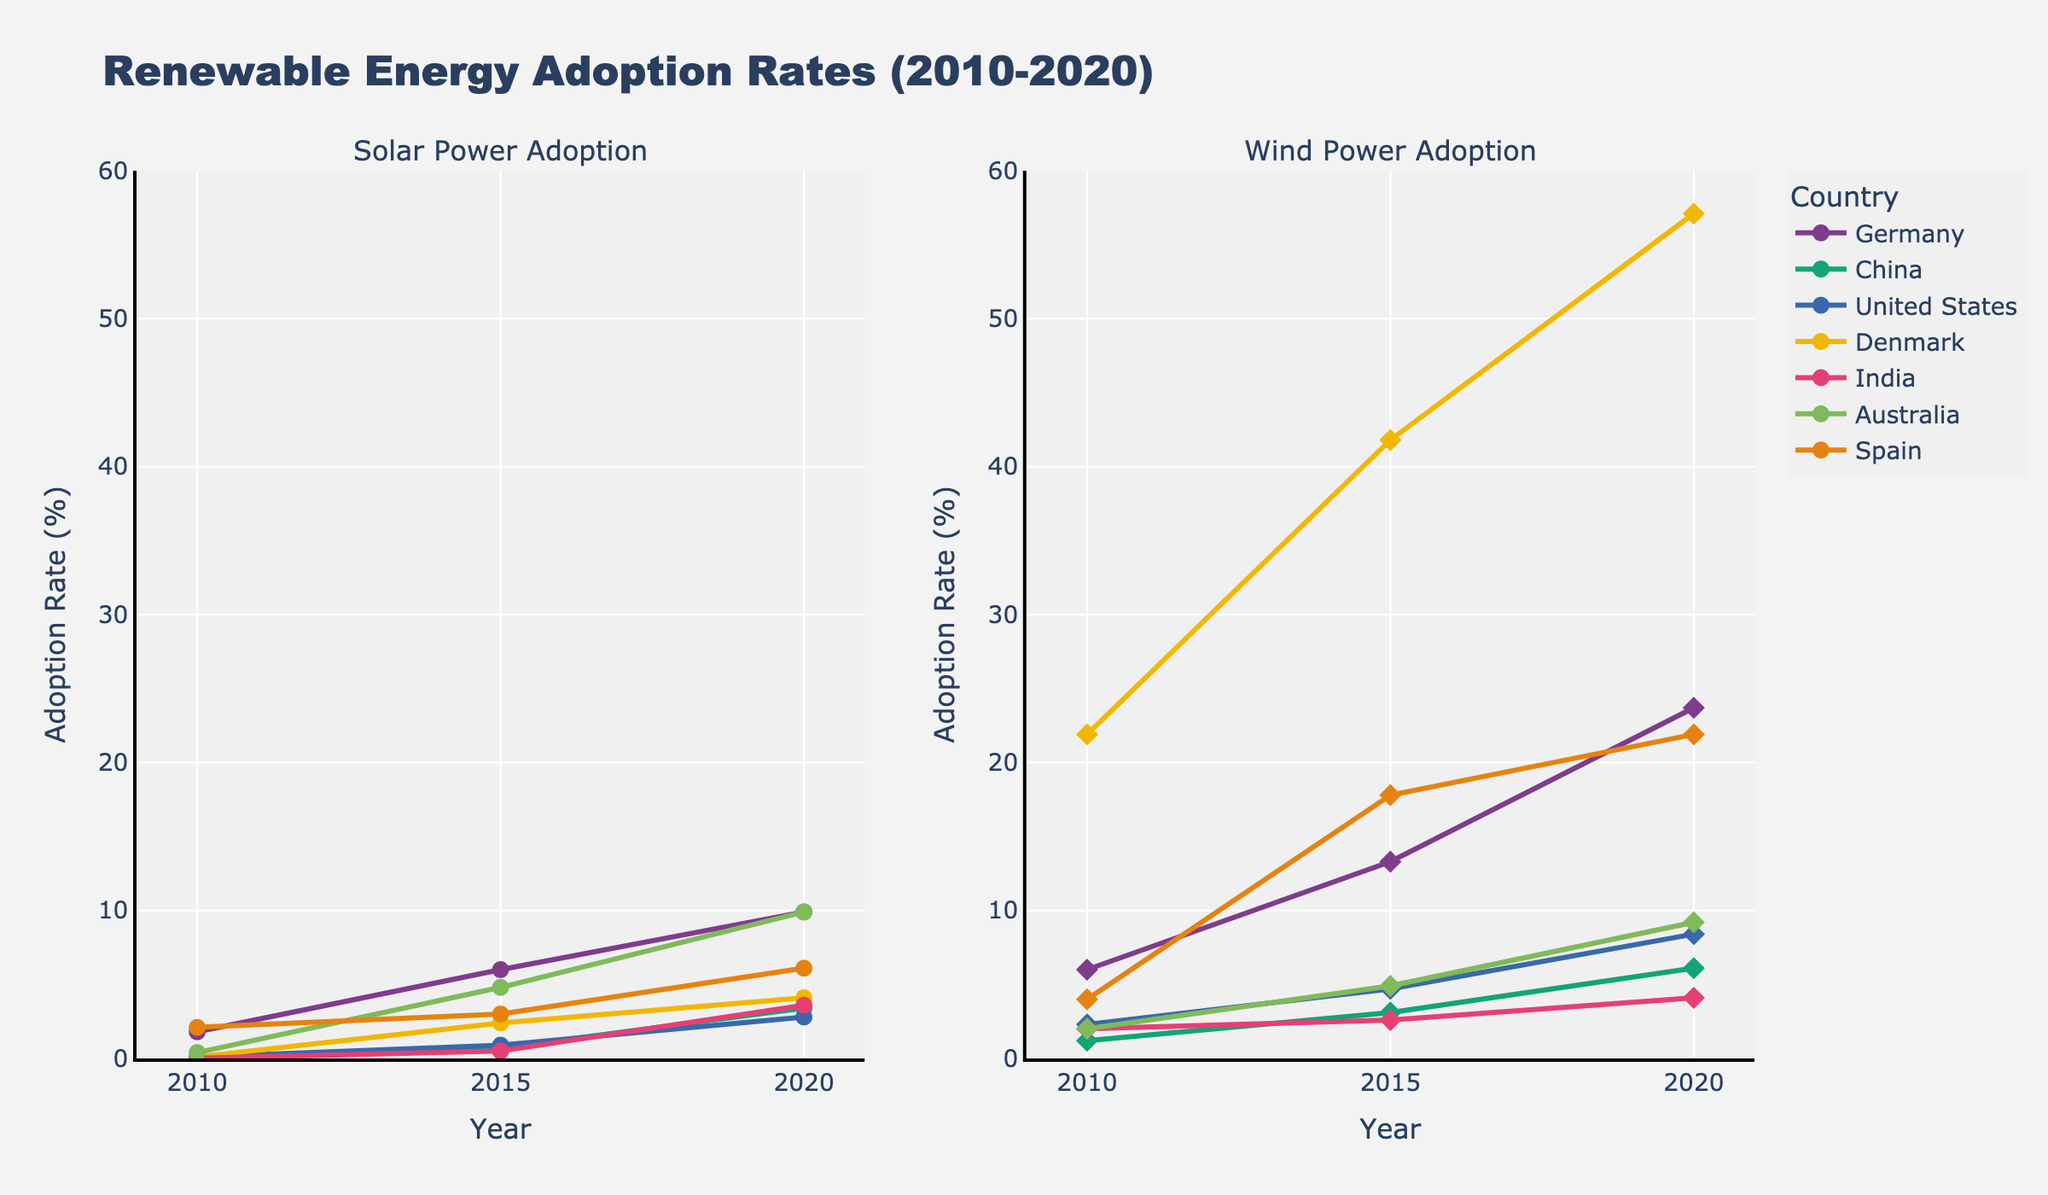What's the difference in solar power adoption rates between Germany and the United States in 2020? From the Solar Power Adoption plot, in 2020, Germany has a solar power adoption rate of 9.9%, and the United States has 2.8%. The difference is 9.9% - 2.8%.
Answer: 7.1% Which country had the highest wind power adoption rate in 2020? From the Wind Power Adoption plot, in 2020, Denmark has the highest wind power adoption rate at 57.1%.
Answer: Denmark How did China's wind power adoption rate change from 2010 to 2020? Comparing the Wind Power Adoption rates for China between 2010 (1.2%) and 2020 (6.1%), the change is 6.1% - 1.2%.
Answer: 4.9% In which year did India have a solar power adoption rate of approximately 3.6%? From the Solar Power Adoption plot, India reached approximately 3.6% in 2020.
Answer: 2020 What's the sum of solar power adoption rates for Australia over the years 2010, 2015, and 2020? The solar power adoption rates for Australia are 0.4% (2010), 4.8% (2015), and 9.9% (2020). Summing these up: 0.4% + 4.8% + 9.9%.
Answer: 15.1% Which country had a greater increase in solar power adoption from 2015 to 2020, Spain or China? From the Solar Power Adoption plot, Spain's increase is 6.1% - 3.0% = 3.1%, and China's increase is 3.4% - 0.7% = 2.7%. Spain had a greater increase.
Answer: Spain Are there any countries with similar wind power adoption rates in 2010? Referring to the Wind Power Adoption plot, the United States (2.3%), India (2.0%), and Australia (2.0%) had similar rates in 2010.
Answer: United States, India, Australia By how much did Denmark's wind power adoption rate exceed Germany's in 2020? From the Wind Power Adoption plot, Denmark's rate in 2020 is 57.1%, and Germany's rate is 23.7%. The difference is 57.1% - 23.7%.
Answer: 33.4% Which country showed the most significant relative growth in solar power adoption from 2010 to 2020? Calculating the relative growth for each country: Germany (9.9%/1.8), China (3.4%/0.01), United States (2.8%/0.1), Denmark (4.1%/0.1), India (3.6%/0.01), Australia (9.9%/0.4), and Spain (6.1%/2.1). China has the most significant relative growth.
Answer: China 